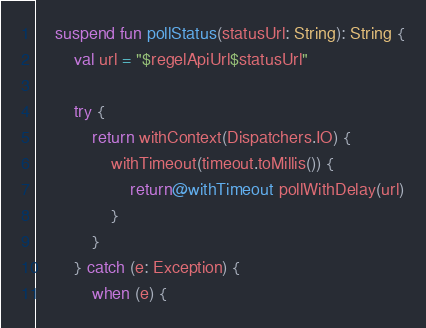Convert code to text. <code><loc_0><loc_0><loc_500><loc_500><_Kotlin_>
    suspend fun pollStatus(statusUrl: String): String {
        val url = "$regelApiUrl$statusUrl"

        try {
            return withContext(Dispatchers.IO) {
                withTimeout(timeout.toMillis()) {
                    return@withTimeout pollWithDelay(url)
                }
            }
        } catch (e: Exception) {
            when (e) {</code> 